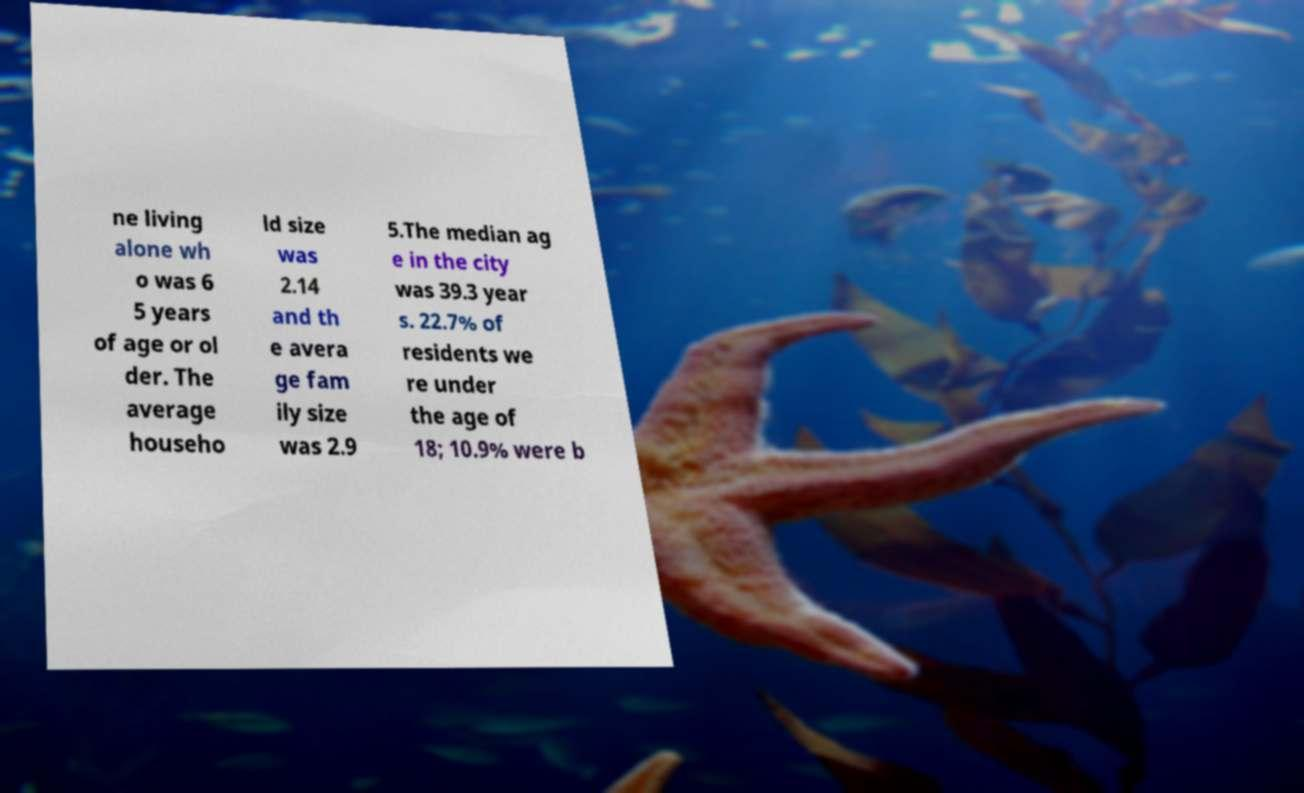Could you extract and type out the text from this image? ne living alone wh o was 6 5 years of age or ol der. The average househo ld size was 2.14 and th e avera ge fam ily size was 2.9 5.The median ag e in the city was 39.3 year s. 22.7% of residents we re under the age of 18; 10.9% were b 